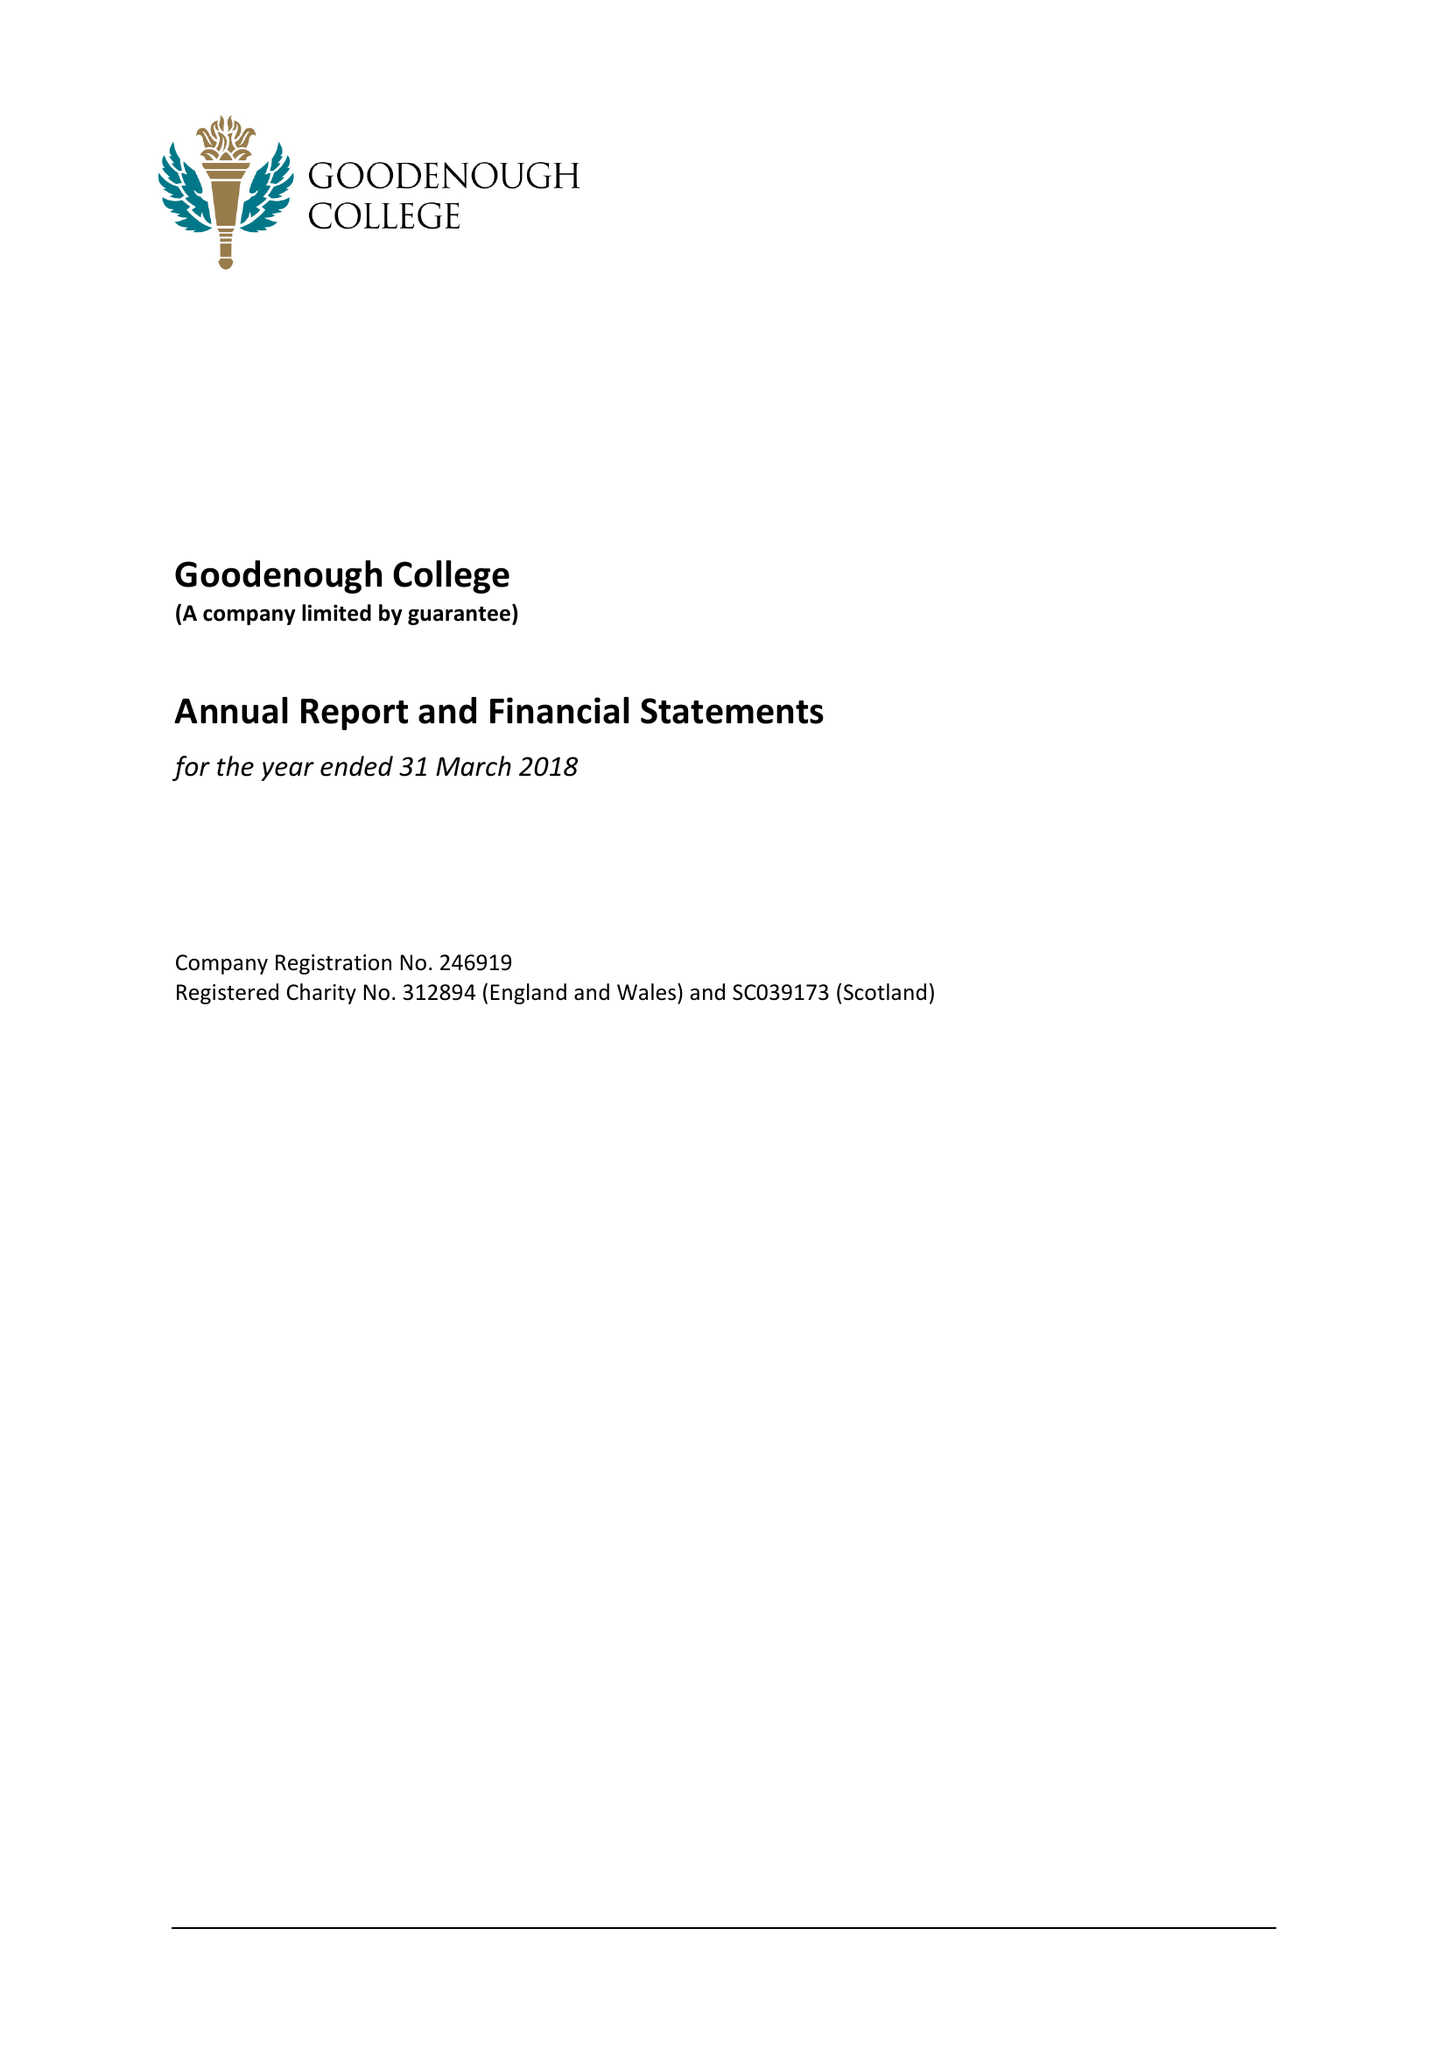What is the value for the address__street_line?
Answer the question using a single word or phrase. MECKLENBURGH SQUARE 